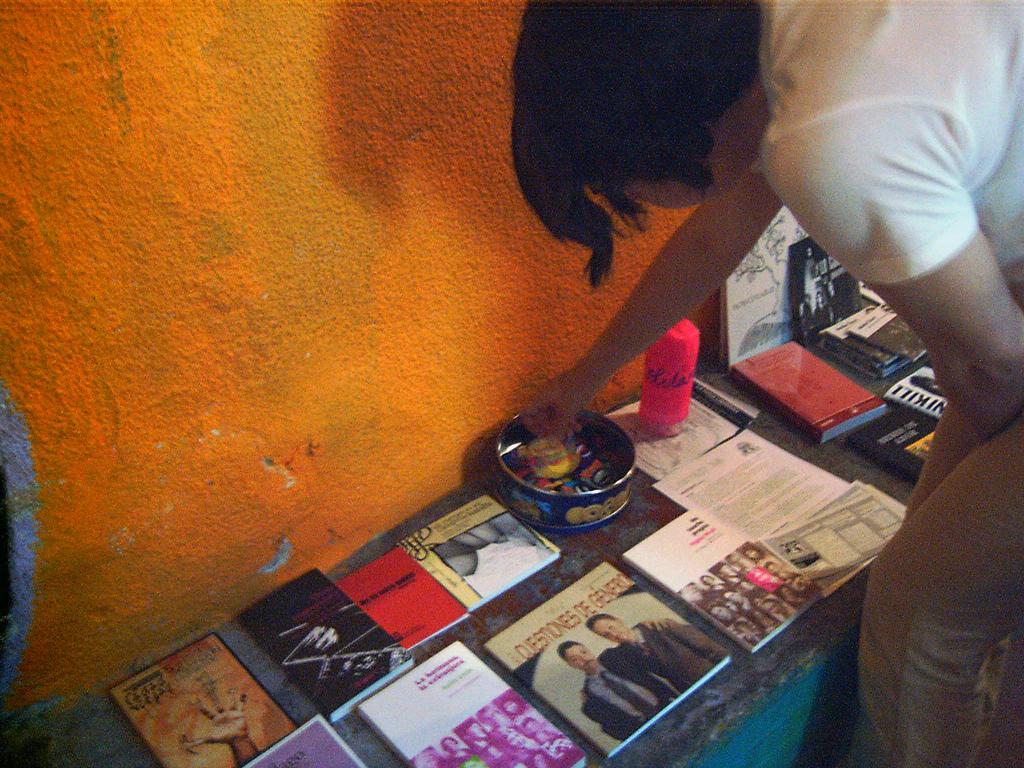Describe this image in one or two sentences. In this image we can see a person on the right side. There is a stand on that. There are many books. Also there is a box with some items. There is a wall near to the stand. 